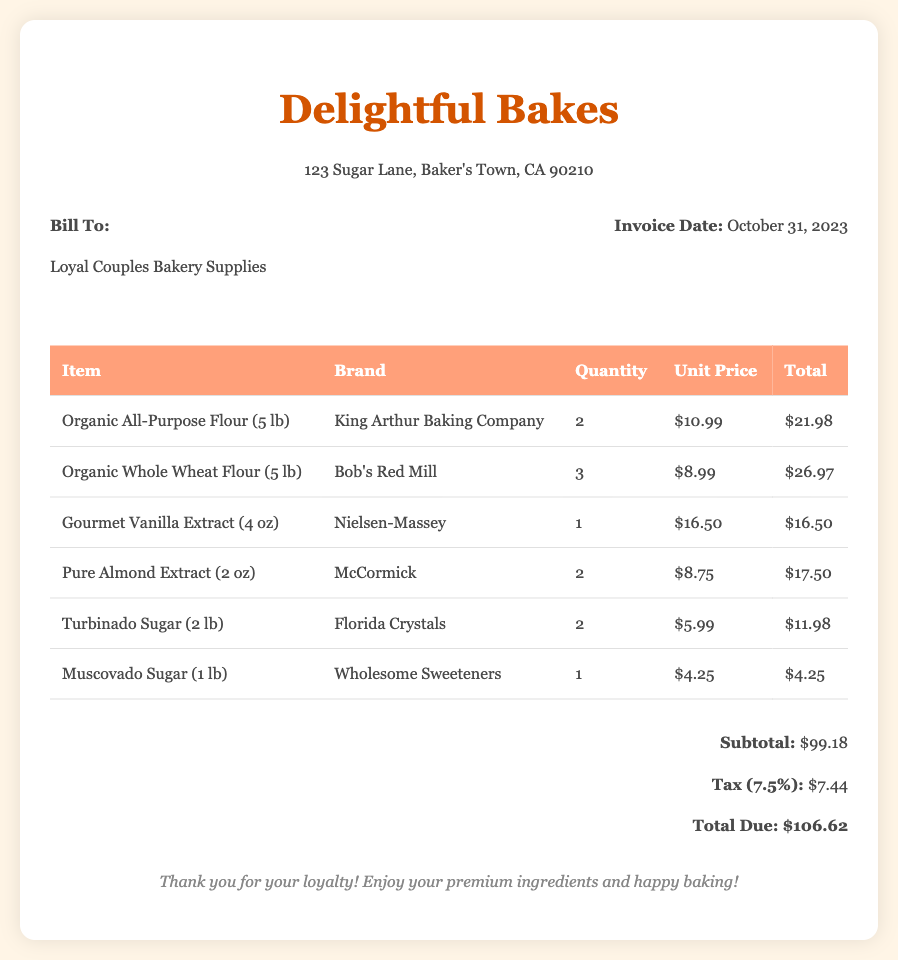What is the invoice date? The invoice date is specified in the document and is found under Invoice Info.
Answer: October 31, 2023 What is the total due amount? The total due amount is summarized at the end of the invoice in the total section.
Answer: $106.62 Who is the bill addressed to? The bill presents a "Bill To" section, which denotes the customer name.
Answer: Loyal Couples Bakery Supplies How many pounds of Organic All-Purpose Flour were purchased? The detailed table lists the quantity of Organic All-Purpose Flour in the "Quantity" column.
Answer: 2 Which brand supplies the Gourmet Vanilla Extract? The brand for the Gourmet Vanilla Extract is indicated in the table under the "Brand" column.
Answer: Nielsen-Massey What is the subtotal amount before tax? The subtotal amount is mentioned in the total section before any taxes are applied.
Answer: $99.18 How many types of sugar were included in the order? The table lists the different sugar items, allowing for a count of types included.
Answer: 2 What is the unit price of Pure Almond Extract? The unit price for Pure Almond Extract can be found in the table under the "Unit Price" column.
Answer: $8.75 What type of payment is accepted for this bill? The document does not include specific payment methods, which is typical for an invoice.
Answer: Not specified What is the percentage of tax applied to the subtotal? The tax rate is given in the total section of the document.
Answer: 7.5% 